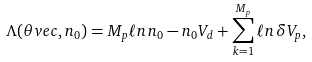Convert formula to latex. <formula><loc_0><loc_0><loc_500><loc_500>\Lambda ( \theta v e c , n _ { 0 } ) = M _ { p } \ell n \, n _ { 0 } - n _ { 0 } V _ { d } + \sum _ { k = 1 } ^ { M _ { p } } \ell n \, \delta V _ { p } ,</formula> 